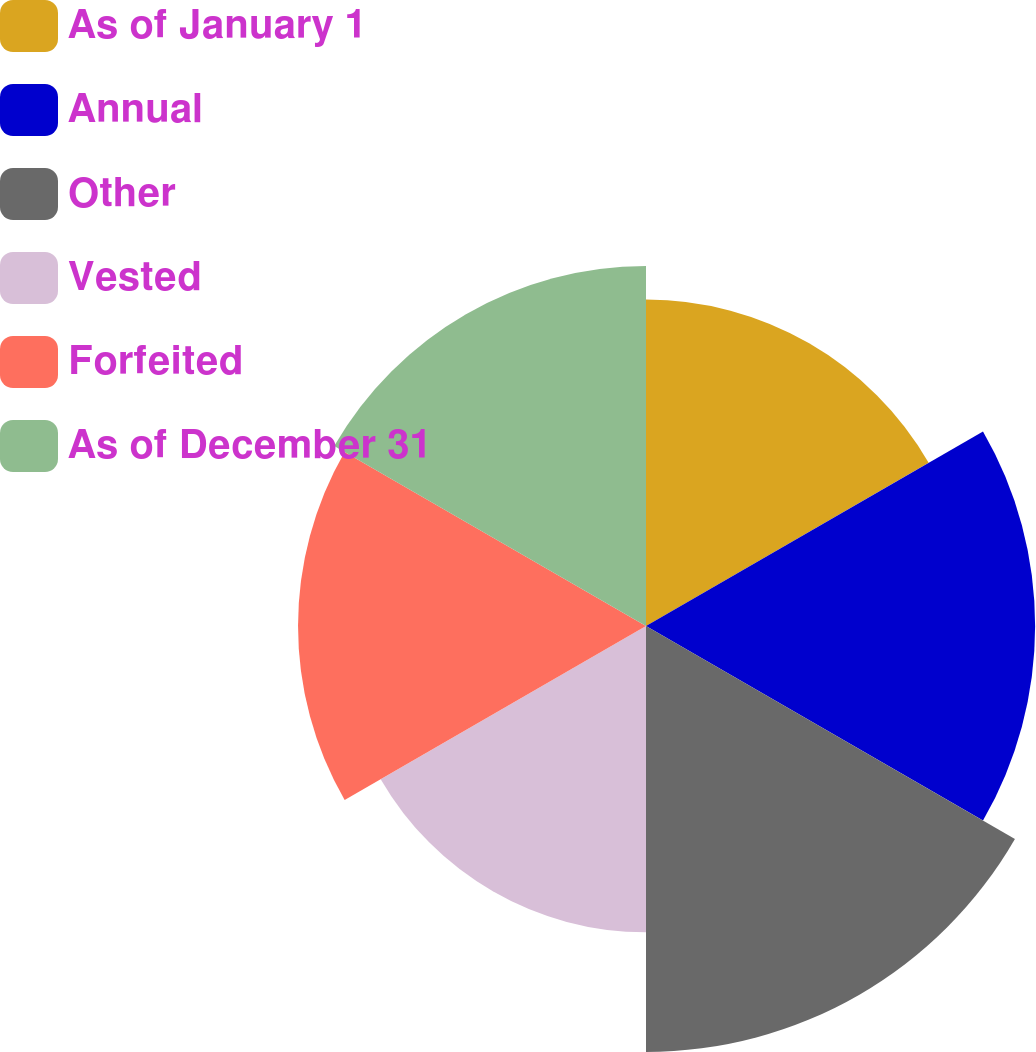Convert chart. <chart><loc_0><loc_0><loc_500><loc_500><pie_chart><fcel>As of January 1<fcel>Annual<fcel>Other<fcel>Vested<fcel>Forfeited<fcel>As of December 31<nl><fcel>15.14%<fcel>18.05%<fcel>19.76%<fcel>14.21%<fcel>16.14%<fcel>16.7%<nl></chart> 